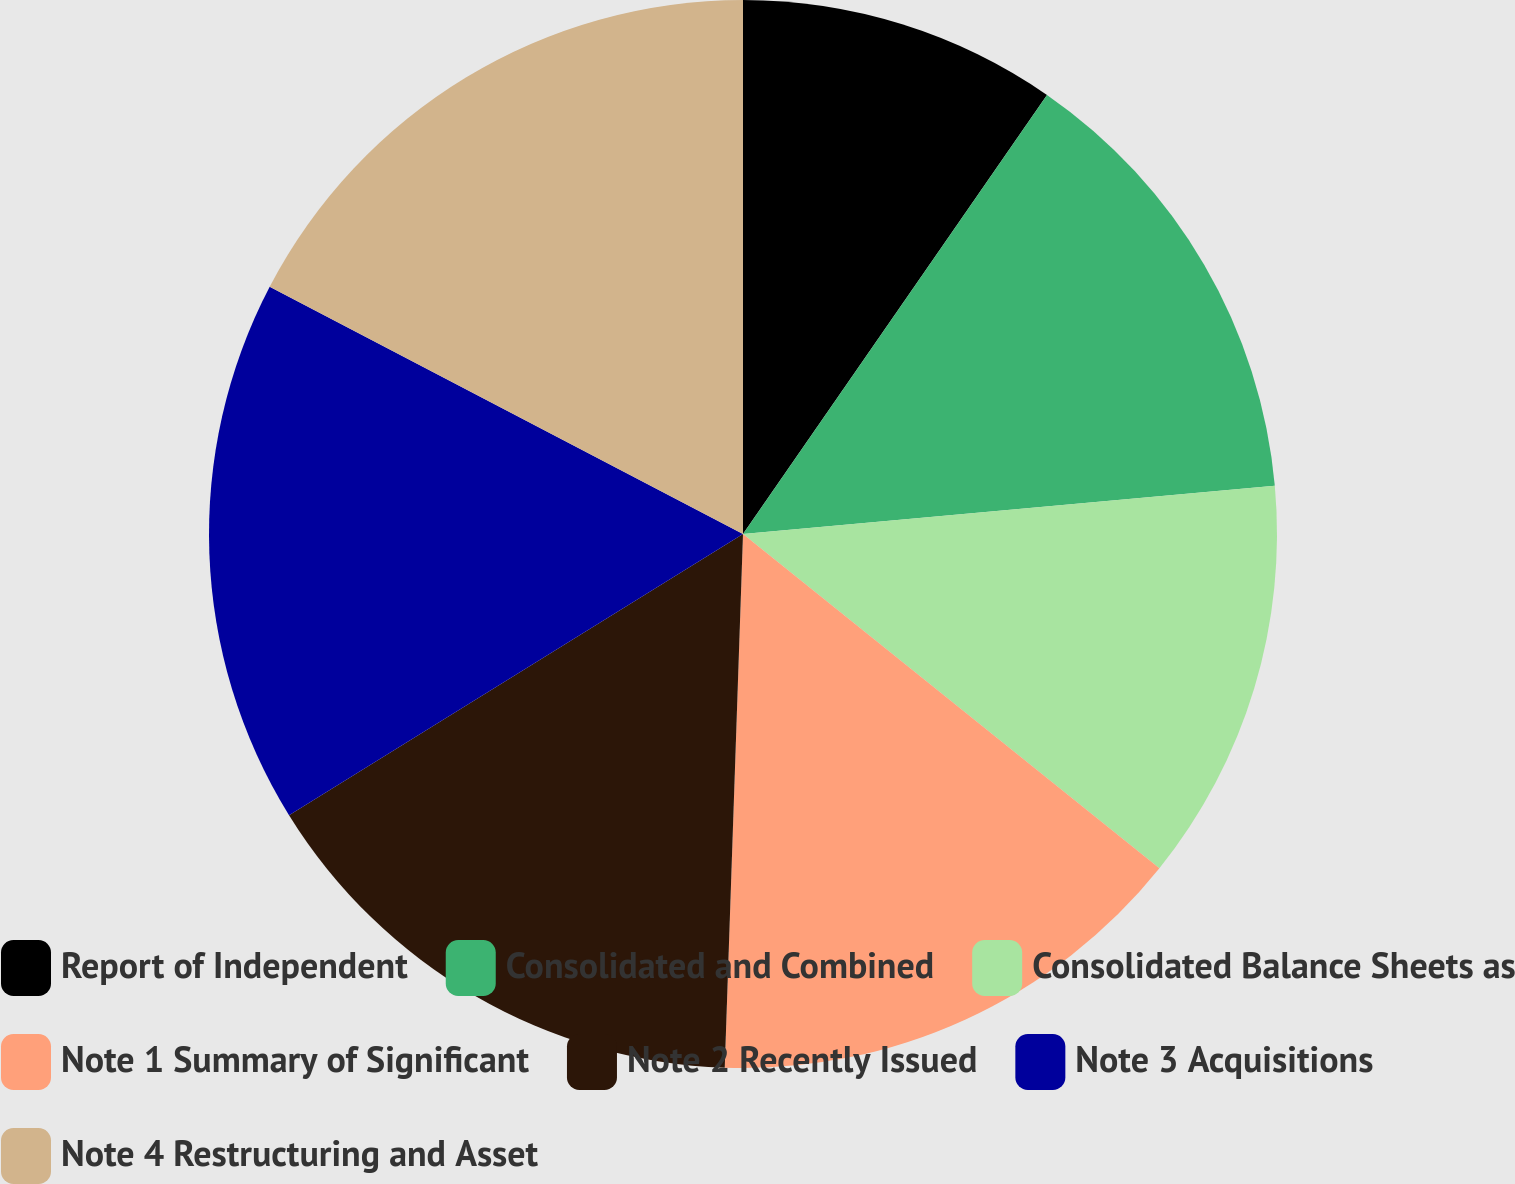Convert chart to OTSL. <chart><loc_0><loc_0><loc_500><loc_500><pie_chart><fcel>Report of Independent<fcel>Consolidated and Combined<fcel>Consolidated Balance Sheets as<fcel>Note 1 Summary of Significant<fcel>Note 2 Recently Issued<fcel>Note 3 Acquisitions<fcel>Note 4 Restructuring and Asset<nl><fcel>9.64%<fcel>13.92%<fcel>12.21%<fcel>14.78%<fcel>15.63%<fcel>16.49%<fcel>17.34%<nl></chart> 